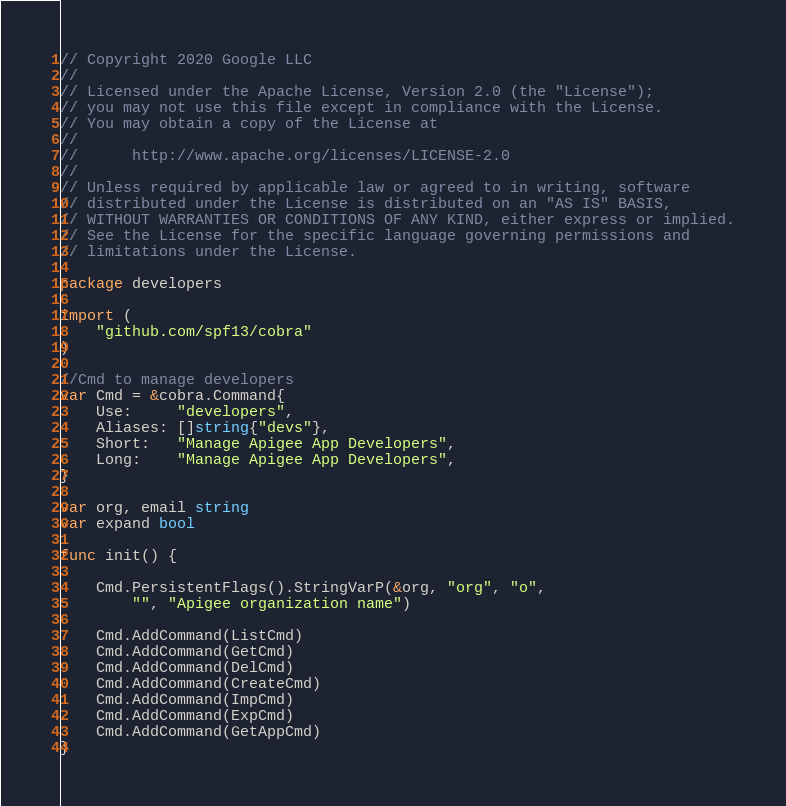<code> <loc_0><loc_0><loc_500><loc_500><_Go_>// Copyright 2020 Google LLC
//
// Licensed under the Apache License, Version 2.0 (the "License");
// you may not use this file except in compliance with the License.
// You may obtain a copy of the License at
//
//      http://www.apache.org/licenses/LICENSE-2.0
//
// Unless required by applicable law or agreed to in writing, software
// distributed under the License is distributed on an "AS IS" BASIS,
// WITHOUT WARRANTIES OR CONDITIONS OF ANY KIND, either express or implied.
// See the License for the specific language governing permissions and
// limitations under the License.

package developers

import (
	"github.com/spf13/cobra"
)

//Cmd to manage developers
var Cmd = &cobra.Command{
	Use:     "developers",
	Aliases: []string{"devs"},
	Short:   "Manage Apigee App Developers",
	Long:    "Manage Apigee App Developers",
}

var org, email string
var expand bool

func init() {

	Cmd.PersistentFlags().StringVarP(&org, "org", "o",
		"", "Apigee organization name")

	Cmd.AddCommand(ListCmd)
	Cmd.AddCommand(GetCmd)
	Cmd.AddCommand(DelCmd)
	Cmd.AddCommand(CreateCmd)
	Cmd.AddCommand(ImpCmd)
	Cmd.AddCommand(ExpCmd)
	Cmd.AddCommand(GetAppCmd)
}
</code> 